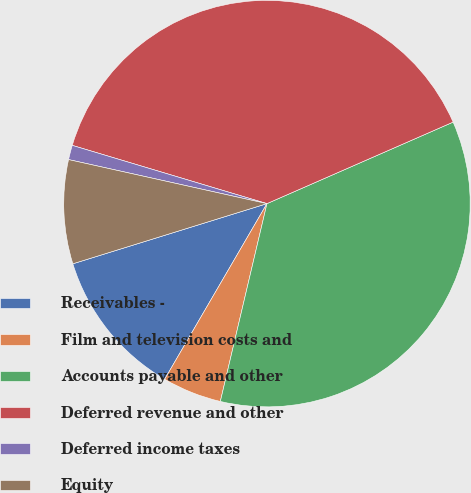Convert chart to OTSL. <chart><loc_0><loc_0><loc_500><loc_500><pie_chart><fcel>Receivables -<fcel>Film and television costs and<fcel>Accounts payable and other<fcel>Deferred revenue and other<fcel>Deferred income taxes<fcel>Equity<nl><fcel>11.82%<fcel>4.71%<fcel>35.25%<fcel>38.8%<fcel>1.15%<fcel>8.26%<nl></chart> 